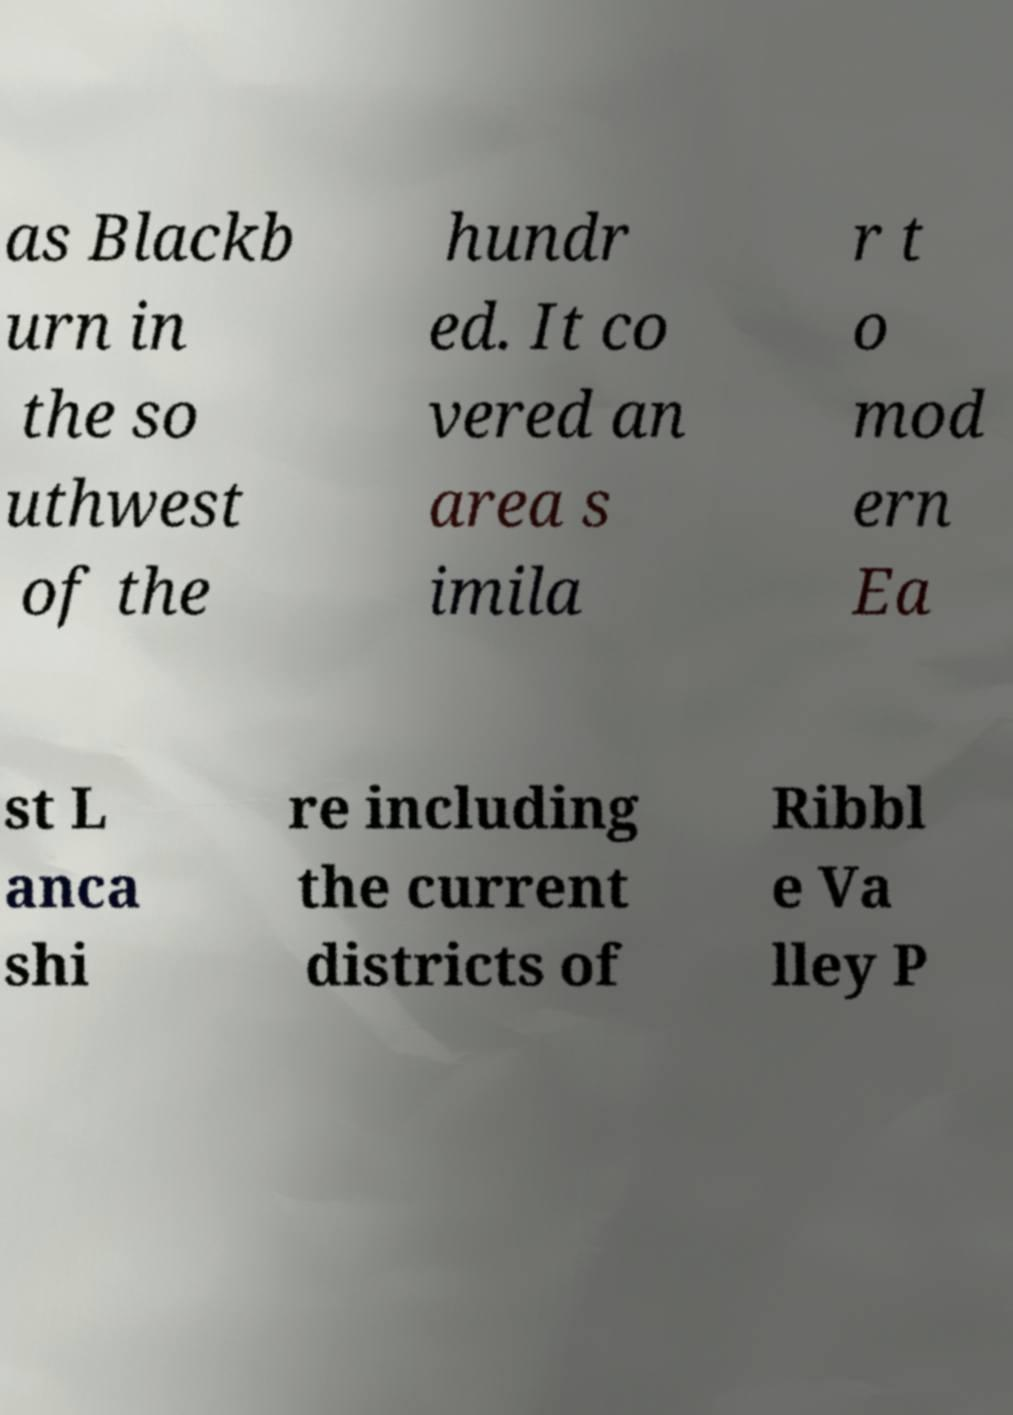There's text embedded in this image that I need extracted. Can you transcribe it verbatim? as Blackb urn in the so uthwest of the hundr ed. It co vered an area s imila r t o mod ern Ea st L anca shi re including the current districts of Ribbl e Va lley P 